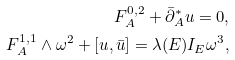Convert formula to latex. <formula><loc_0><loc_0><loc_500><loc_500>F _ { A } ^ { 0 , 2 } + \bar { \partial } _ { A } ^ { * } u = 0 , \\ F _ { A } ^ { 1 , 1 } \wedge \omega ^ { 2 } + [ u , \bar { u } ] = \lambda ( E ) I _ { E } \omega ^ { 3 } ,</formula> 